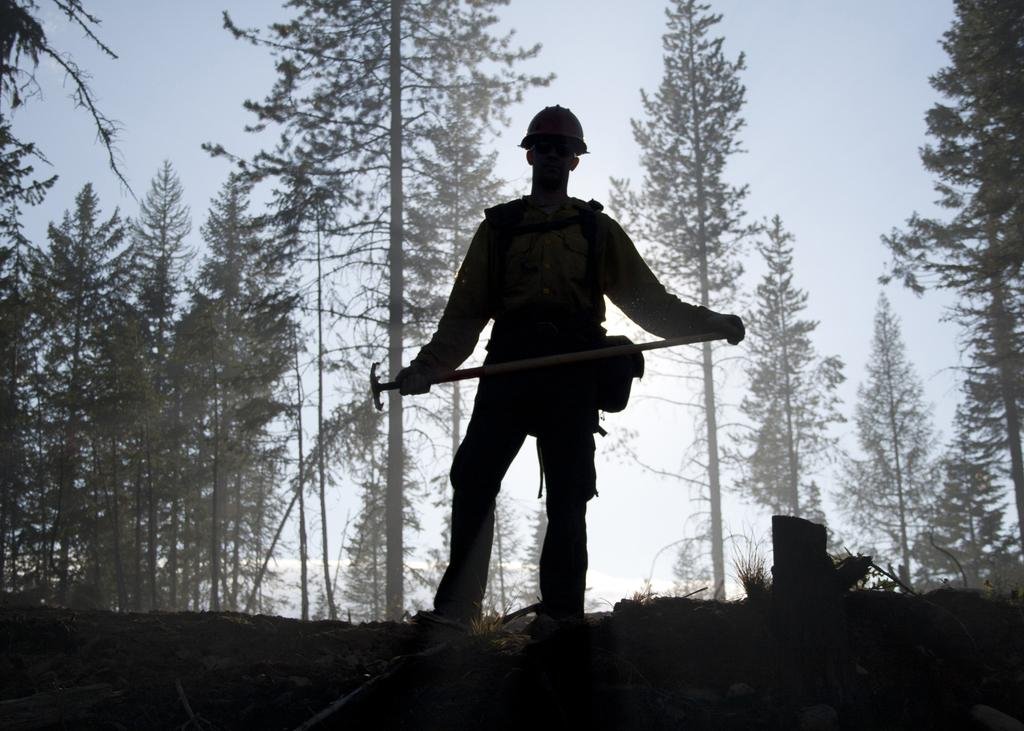What is present in the image? There is a person in the image. What is the person holding in their hands? The person is holding something in their hands. What can be seen in the background of the image? There are trees and the sky visible in the background of the image. Can you tell me how many jellyfish are swimming in the image? There are no jellyfish present in the image; it features a person holding something in their hands with trees and the sky visible in the background. 